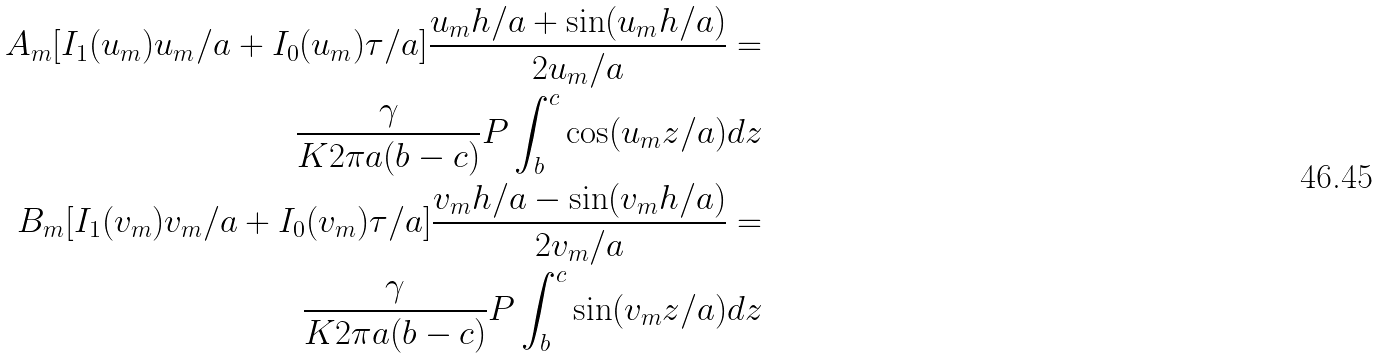Convert formula to latex. <formula><loc_0><loc_0><loc_500><loc_500>A _ { m } [ I _ { 1 } ( u _ { m } ) u _ { m } / a + I _ { 0 } ( u _ { m } ) \tau / a ] \frac { u _ { m } h / a + \sin ( u _ { m } h / a ) } { 2 u _ { m } / a } = \\ \frac { \gamma } { K 2 \pi a ( b - c ) } P \int _ { b } ^ { c } \cos ( u _ { m } z / a ) d z \\ B _ { m } [ I _ { 1 } ( v _ { m } ) v _ { m } / a + I _ { 0 } ( v _ { m } ) \tau / a ] \frac { v _ { m } h / a - \sin ( v _ { m } h / a ) } { 2 v _ { m } / a } = \\ \frac { \gamma } { K 2 \pi a ( b - c ) } P \int _ { b } ^ { c } \sin ( v _ { m } z / a ) d z</formula> 